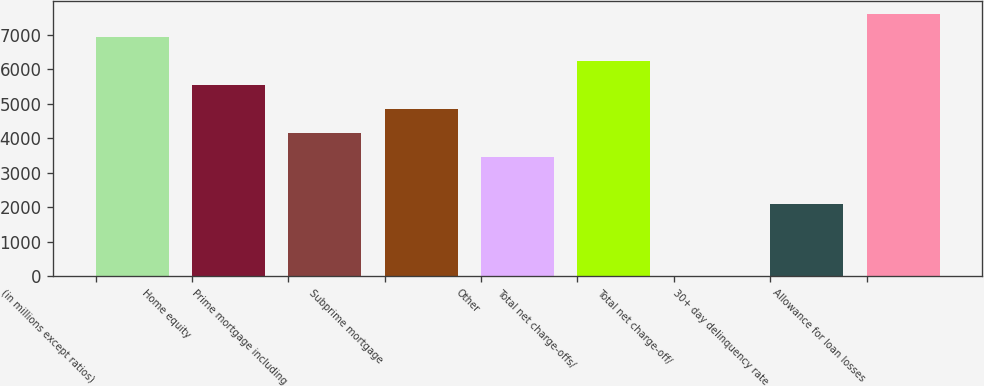Convert chart. <chart><loc_0><loc_0><loc_500><loc_500><bar_chart><fcel>(in millions except ratios)<fcel>Home equity<fcel>Prime mortgage including<fcel>Subprime mortgage<fcel>Other<fcel>Total net charge-offs/<fcel>Total net charge-off/<fcel>30+ day delinquency rate<fcel>Allowance for loan losses<nl><fcel>6919.04<fcel>5535.36<fcel>4151.68<fcel>4843.52<fcel>3459.84<fcel>6227.2<fcel>0.64<fcel>2076.16<fcel>7610.88<nl></chart> 